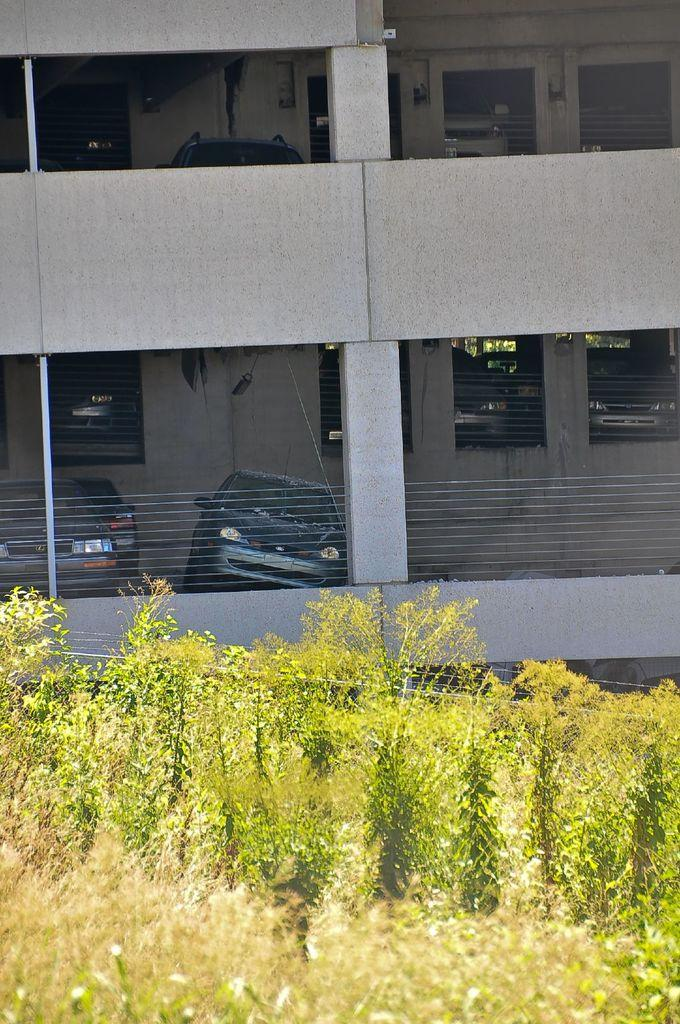What type of vegetation can be seen on the land in the image? There are plants on the land in the image. What can be seen in the distance behind the plants? There is a building in the background of the image. What type of vehicles are parked in the image? There are cars parked in a parking lot in the image. Where can the toothpaste be found in the image? There is no toothpaste present in the image. How many clocks are visible in the image? There are no clocks visible in the image. 